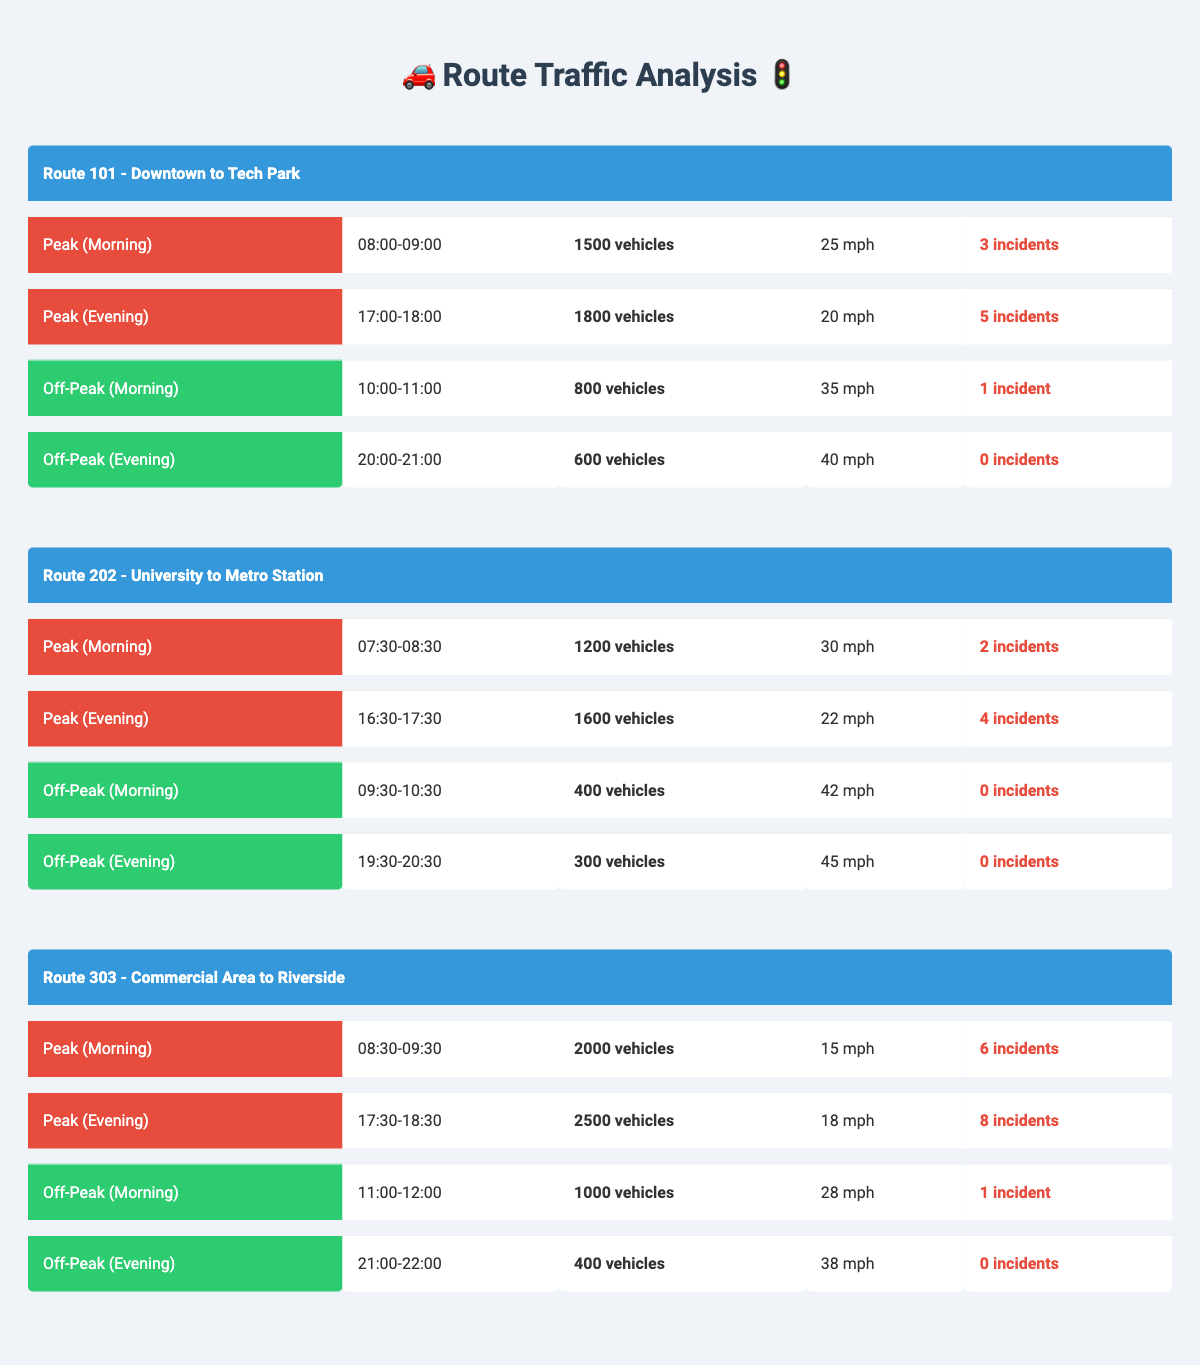What is the traffic volume on Route 101 during the evening peak hour? The evening peak hour for Route 101 is from 17:00 to 18:00, during which the traffic volume is 1800 vehicles.
Answer: 1800 vehicles What is the average speed on Route 202 during the morning off-peak hour? The morning off-peak hour for Route 202 is from 09:30 to 10:30, where the average speed is 42 mph.
Answer: 42 mph How many incidents were reported on Route 303 during its evening peak hour? The evening peak hour for Route 303 is from 17:30 to 18:30, during which there were 8 incidents reported.
Answer: 8 incidents Is the average speed during the morning peak hour on Route 101 greater than that of Route 202? For Route 101, the morning peak speed is 25 mph, while for Route 202, it's 30 mph. Since 25 is less than 30, the statement is false.
Answer: No What is the total traffic volume for Route 101 during both peak hours? For Route 101, the morning peak traffic volume is 1500 and the evening peak is 1800. Adding them gives 1500 + 1800 = 3300 vehicles.
Answer: 3300 vehicles What was the highest traffic volume recorded during peak hours across all routes? The highest traffic volume during peak hours is on Route 303 in the evening with 2500 vehicles.
Answer: 2500 vehicles How does the traffic volume during off-peak hours on Route 202 compare to that on Route 303? Route 202 has 400 vehicles during morning off-peak and 300 during evening while Route 303 has 1000 during morning off-peak and 400 during evening. Comparing, Route 303 has higher volumes in both off-peak periods.
Answer: Route 303 has higher volumes What is the difference in incidents between the evening peak hour and morning peak hour on Route 303? The evening peak hour has 8 incidents and the morning peak hour has 6 incidents. The difference is 8 - 6 = 2 incidents.
Answer: 2 incidents During which route's morning off-peak hour were the most vehicles recorded? Route 303's morning off-peak hour shows 1000 vehicles, which is the highest compared to 400 vehicles on Route 202.
Answer: Route 303 What percentage of the incidents during the peak hours for Route 101 occurred in the evening? Route 101 had a total of 8 incidents (3 in the morning and 5 in the evening). The percentage for evening incidents is (5 incidents evening / 8 total incidents) * 100 = 62.5%.
Answer: 62.5% Which route had the highest average speed during off-peak hours? Route 202 had the highest average speed of 45 mph during its evening off-peak hour, compared to 40 mph for Route 101 and 38 mph for Route 303.
Answer: Route 202 